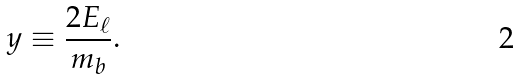Convert formula to latex. <formula><loc_0><loc_0><loc_500><loc_500>y \equiv \frac { 2 E _ { \ell } } { m _ { b } } .</formula> 